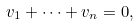<formula> <loc_0><loc_0><loc_500><loc_500>v _ { 1 } + \cdots + v _ { n } = 0 ,</formula> 